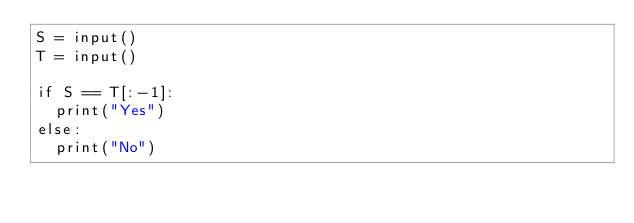Convert code to text. <code><loc_0><loc_0><loc_500><loc_500><_Python_>S = input()
T = input()

if S == T[:-1]:
  print("Yes")
else:
  print("No")</code> 